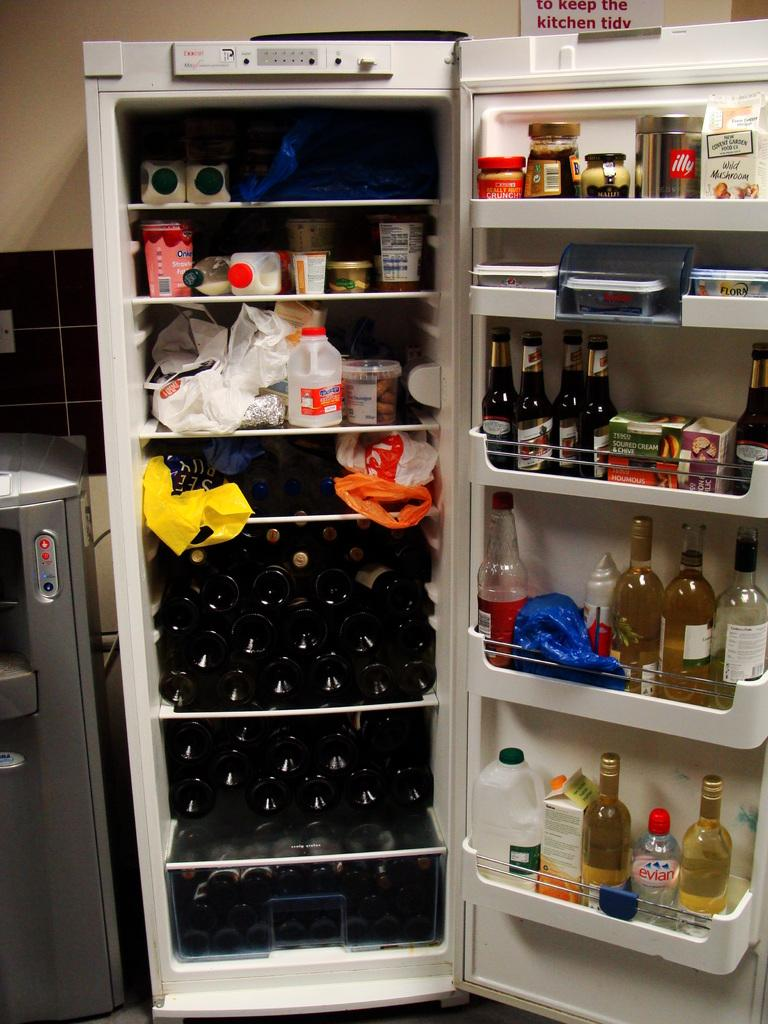Provide a one-sentence caption for the provided image. An open fridge wine bottles filling up the bottom half and a sign behind that says to keep the kitchen tidy. 